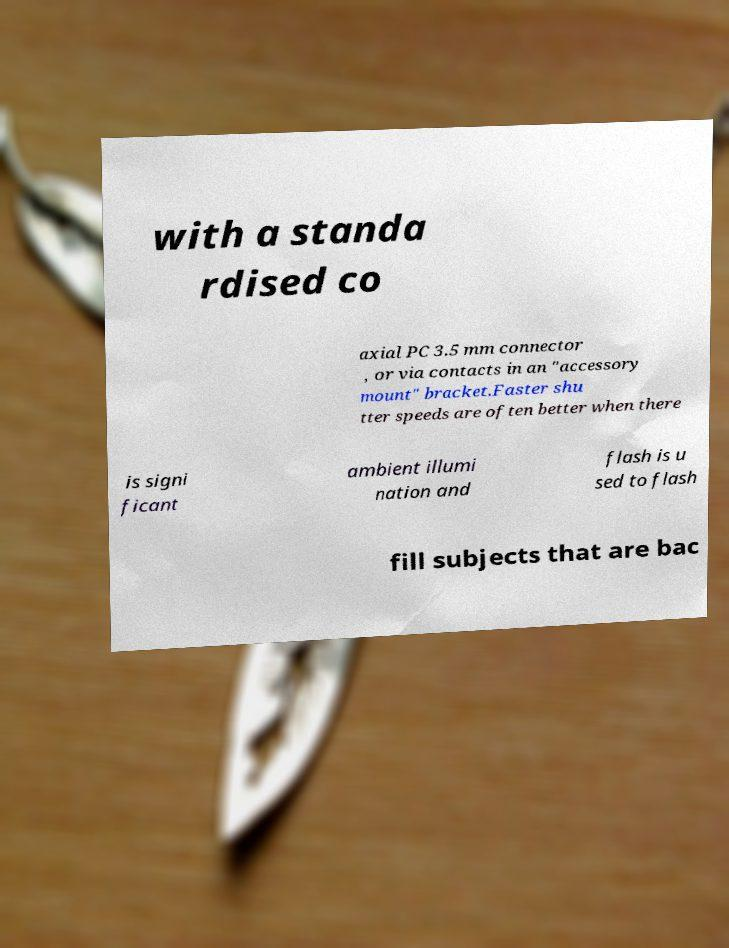Could you assist in decoding the text presented in this image and type it out clearly? with a standa rdised co axial PC 3.5 mm connector , or via contacts in an "accessory mount" bracket.Faster shu tter speeds are often better when there is signi ficant ambient illumi nation and flash is u sed to flash fill subjects that are bac 